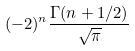Convert formula to latex. <formula><loc_0><loc_0><loc_500><loc_500>( - 2 ) ^ { n } \frac { \Gamma ( n + 1 / 2 ) } { \sqrt { \pi } }</formula> 